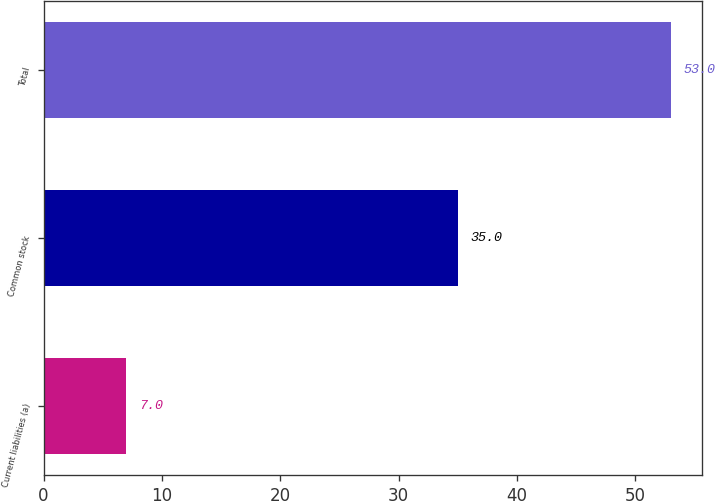<chart> <loc_0><loc_0><loc_500><loc_500><bar_chart><fcel>Current liabilities (a)<fcel>Common stock<fcel>Total<nl><fcel>7<fcel>35<fcel>53<nl></chart> 